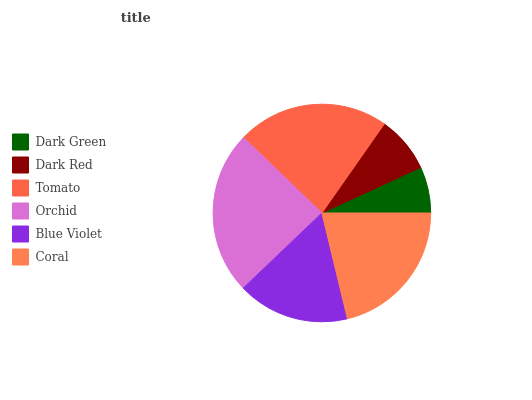Is Dark Green the minimum?
Answer yes or no. Yes. Is Orchid the maximum?
Answer yes or no. Yes. Is Dark Red the minimum?
Answer yes or no. No. Is Dark Red the maximum?
Answer yes or no. No. Is Dark Red greater than Dark Green?
Answer yes or no. Yes. Is Dark Green less than Dark Red?
Answer yes or no. Yes. Is Dark Green greater than Dark Red?
Answer yes or no. No. Is Dark Red less than Dark Green?
Answer yes or no. No. Is Coral the high median?
Answer yes or no. Yes. Is Blue Violet the low median?
Answer yes or no. Yes. Is Tomato the high median?
Answer yes or no. No. Is Orchid the low median?
Answer yes or no. No. 